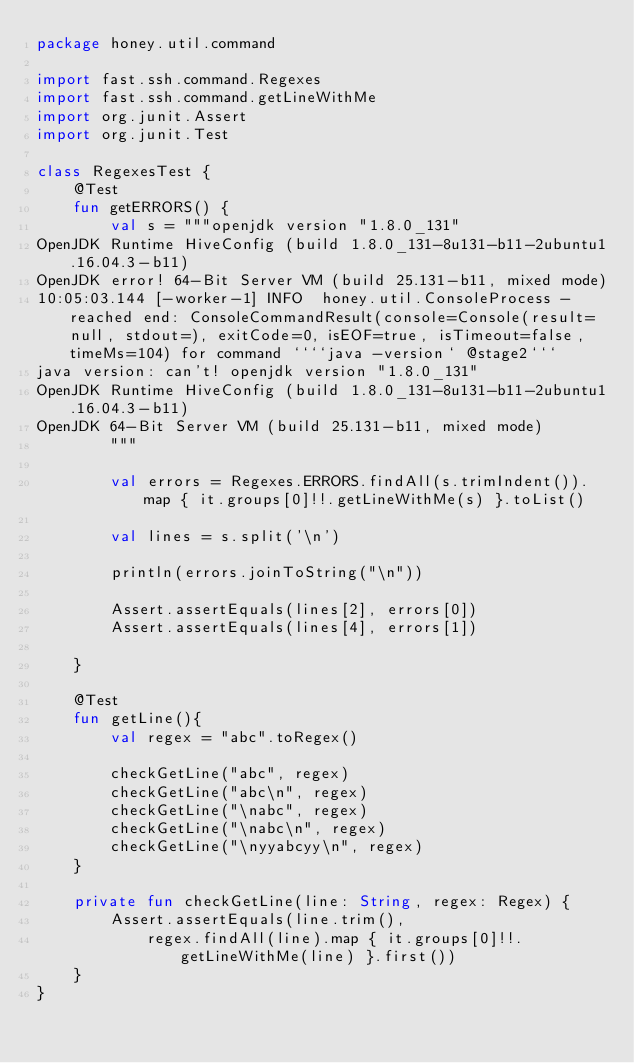Convert code to text. <code><loc_0><loc_0><loc_500><loc_500><_Kotlin_>package honey.util.command

import fast.ssh.command.Regexes
import fast.ssh.command.getLineWithMe
import org.junit.Assert
import org.junit.Test

class RegexesTest {
    @Test
    fun getERRORS() {
        val s = """openjdk version "1.8.0_131"
OpenJDK Runtime HiveConfig (build 1.8.0_131-8u131-b11-2ubuntu1.16.04.3-b11)
OpenJDK error! 64-Bit Server VM (build 25.131-b11, mixed mode)
10:05:03.144 [-worker-1] INFO  honey.util.ConsoleProcess - reached end: ConsoleCommandResult(console=Console(result=null, stdout=), exitCode=0, isEOF=true, isTimeout=false, timeMs=104) for command ````java -version` @stage2```
java version: can't! openjdk version "1.8.0_131"
OpenJDK Runtime HiveConfig (build 1.8.0_131-8u131-b11-2ubuntu1.16.04.3-b11)
OpenJDK 64-Bit Server VM (build 25.131-b11, mixed mode)
        """

        val errors = Regexes.ERRORS.findAll(s.trimIndent()).map { it.groups[0]!!.getLineWithMe(s) }.toList()

        val lines = s.split('\n')

        println(errors.joinToString("\n"))

        Assert.assertEquals(lines[2], errors[0])
        Assert.assertEquals(lines[4], errors[1])

    }

    @Test
    fun getLine(){
        val regex = "abc".toRegex()

        checkGetLine("abc", regex)
        checkGetLine("abc\n", regex)
        checkGetLine("\nabc", regex)
        checkGetLine("\nabc\n", regex)
        checkGetLine("\nyyabcyy\n", regex)
    }

    private fun checkGetLine(line: String, regex: Regex) {
        Assert.assertEquals(line.trim(),
            regex.findAll(line).map { it.groups[0]!!.getLineWithMe(line) }.first())
    }
}

</code> 